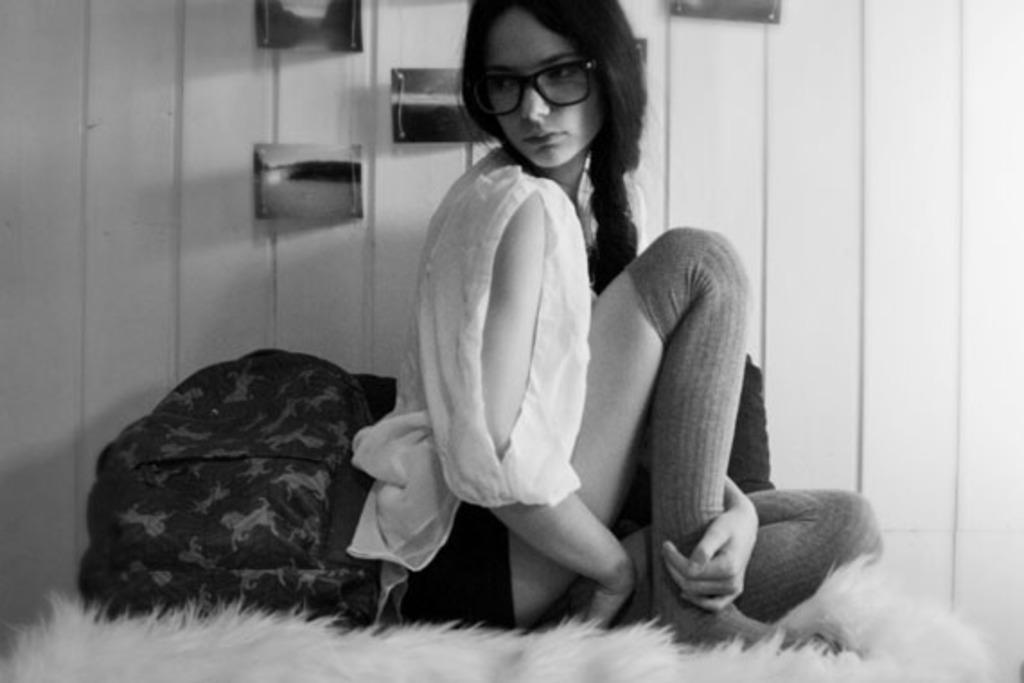Could you give a brief overview of what you see in this image? In this image I can see a woman is sitting on an object. The woman is wearing spectacles. Here I can see an object. In the background I can see a wall which has some objects attached to it. This picture is black and white in color. 